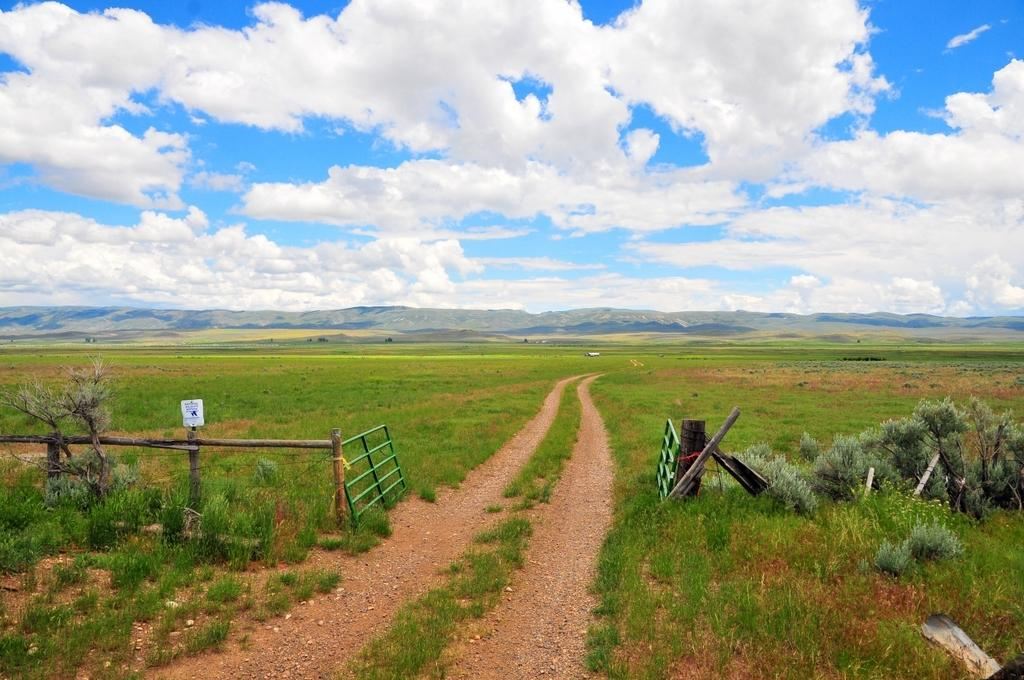What type of structure can be seen in the image? There is fencing and a gate in the image. What can be found beyond the gate in the image? There are fields visible in the image. What is visible in the background of the image? There is a mountain and the sky in the background of the image. What invention is being demonstrated in the image? There is no invention being demonstrated in the image; it features fencing, a gate, fields, a mountain, and the sky. What rhythm can be heard in the image? There is no sound or rhythm present in the image; it is a still image. 